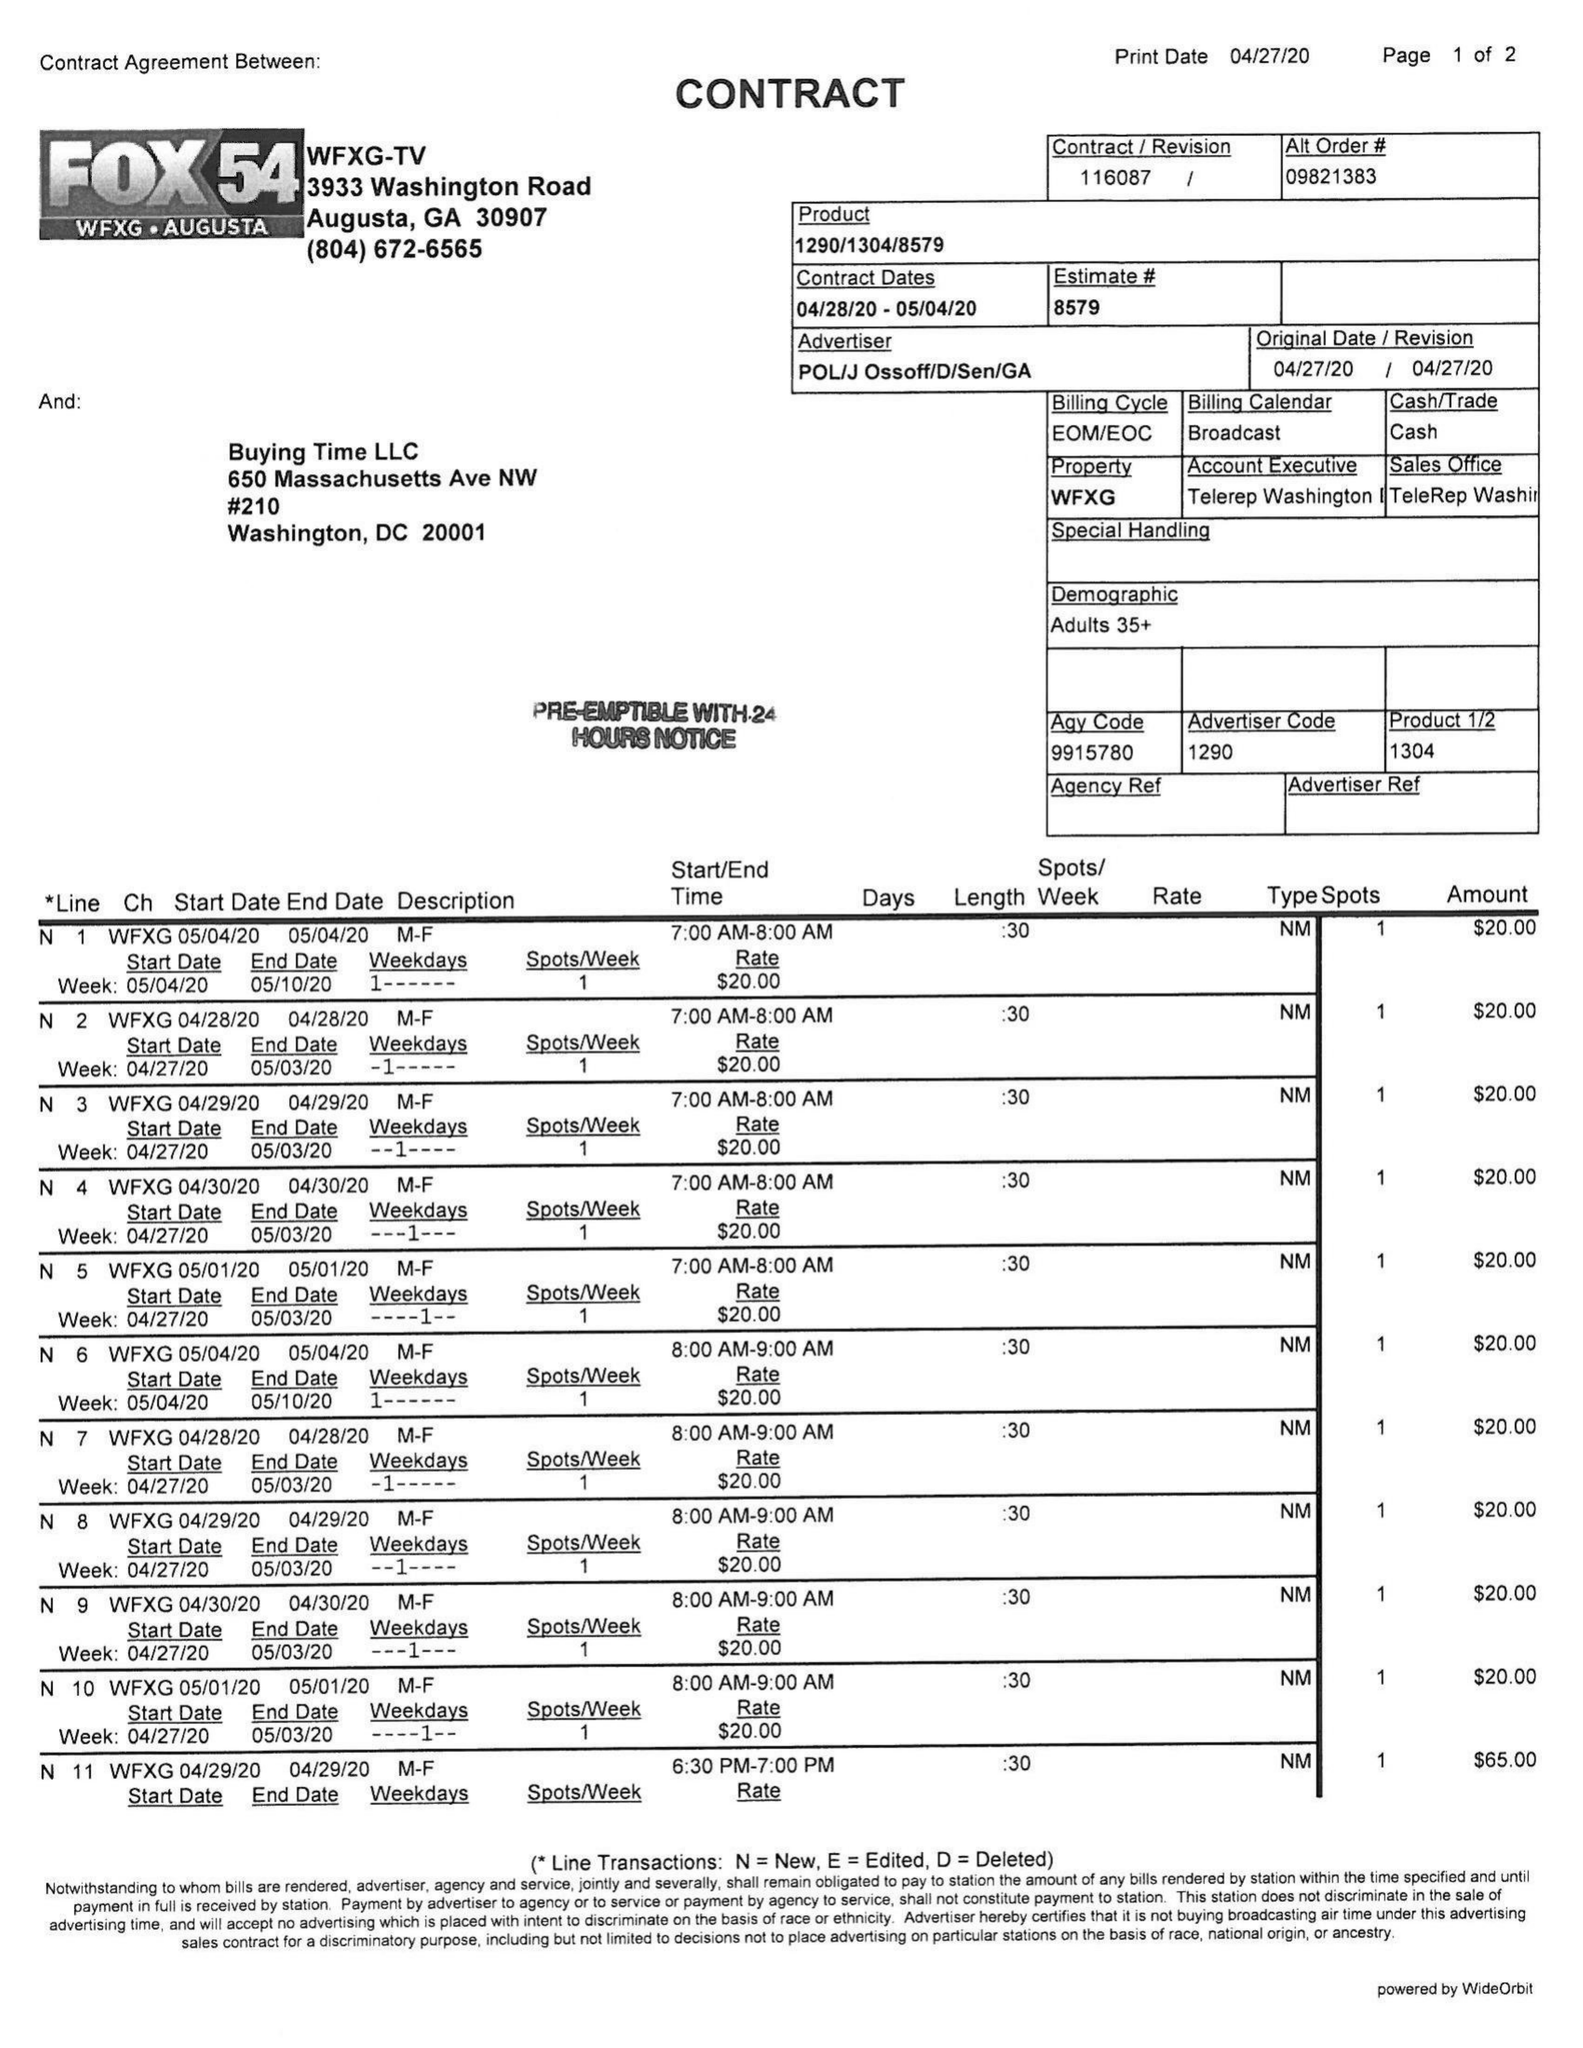What is the value for the flight_to?
Answer the question using a single word or phrase. 05/04/20 